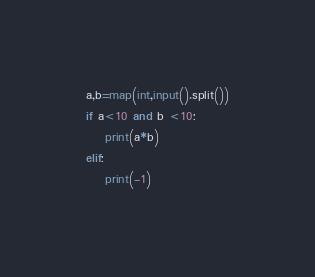Convert code to text. <code><loc_0><loc_0><loc_500><loc_500><_Python_>a,b=map(int,input().split())
if a<10 and b <10:
	print(a*b)
elif:
    print(-1)</code> 